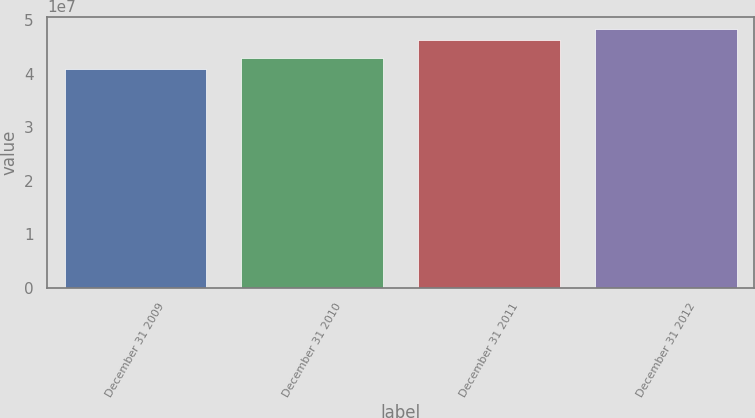Convert chart to OTSL. <chart><loc_0><loc_0><loc_500><loc_500><bar_chart><fcel>December 31 2009<fcel>December 31 2010<fcel>December 31 2011<fcel>December 31 2012<nl><fcel>4.0946e+07<fcel>4.30121e+07<fcel>4.63095e+07<fcel>4.83134e+07<nl></chart> 